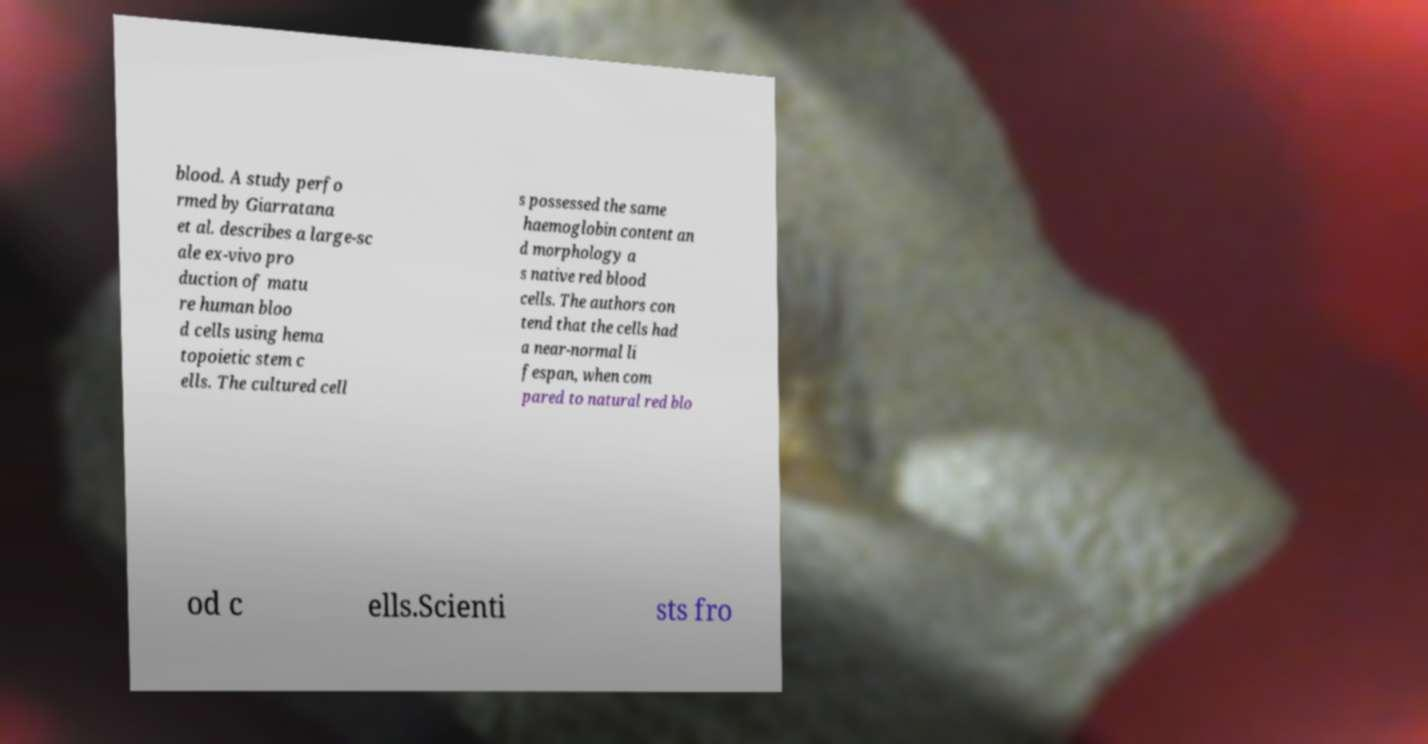For documentation purposes, I need the text within this image transcribed. Could you provide that? blood. A study perfo rmed by Giarratana et al. describes a large-sc ale ex-vivo pro duction of matu re human bloo d cells using hema topoietic stem c ells. The cultured cell s possessed the same haemoglobin content an d morphology a s native red blood cells. The authors con tend that the cells had a near-normal li fespan, when com pared to natural red blo od c ells.Scienti sts fro 